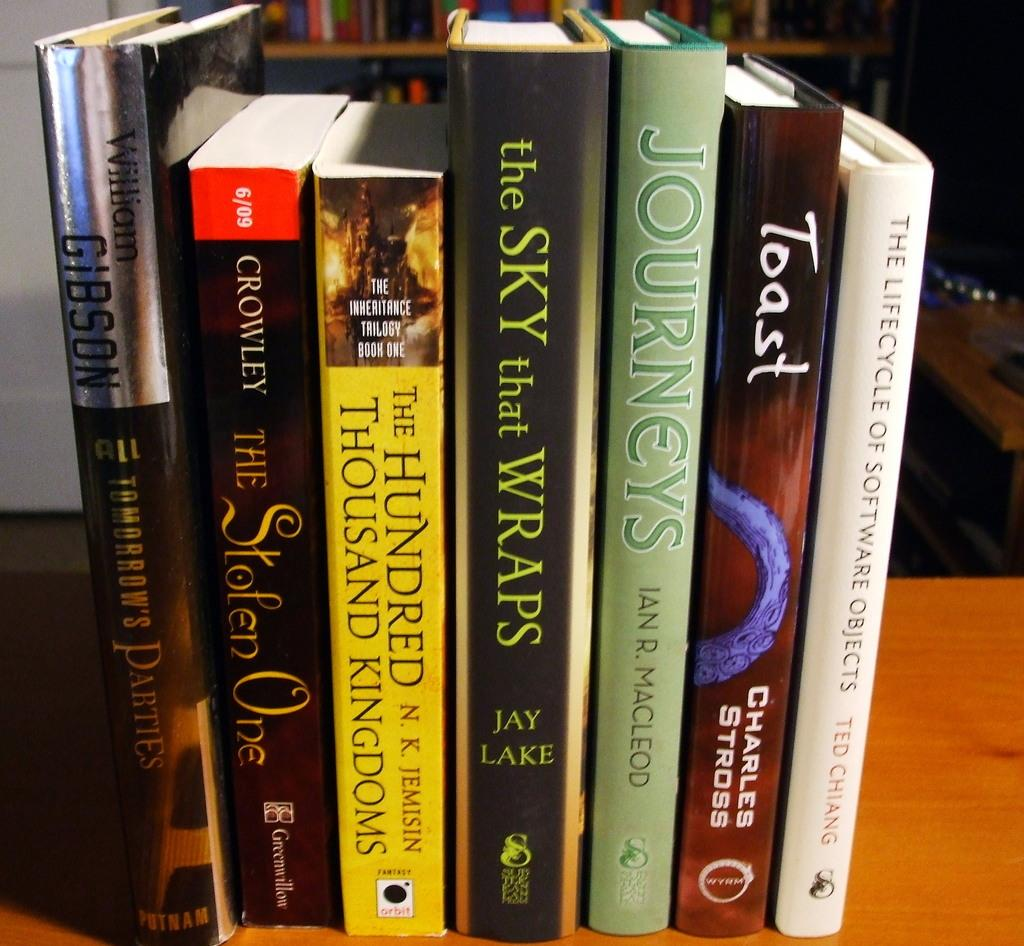Provide a one-sentence caption for the provided image. A book called Toast by Charles Stross is next to a book by Ted Chiang. 